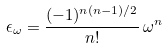<formula> <loc_0><loc_0><loc_500><loc_500>\epsilon _ { \omega } = \frac { ( - 1 ) ^ { n ( n - 1 ) / 2 } } { n ! } \, \omega ^ { n }</formula> 